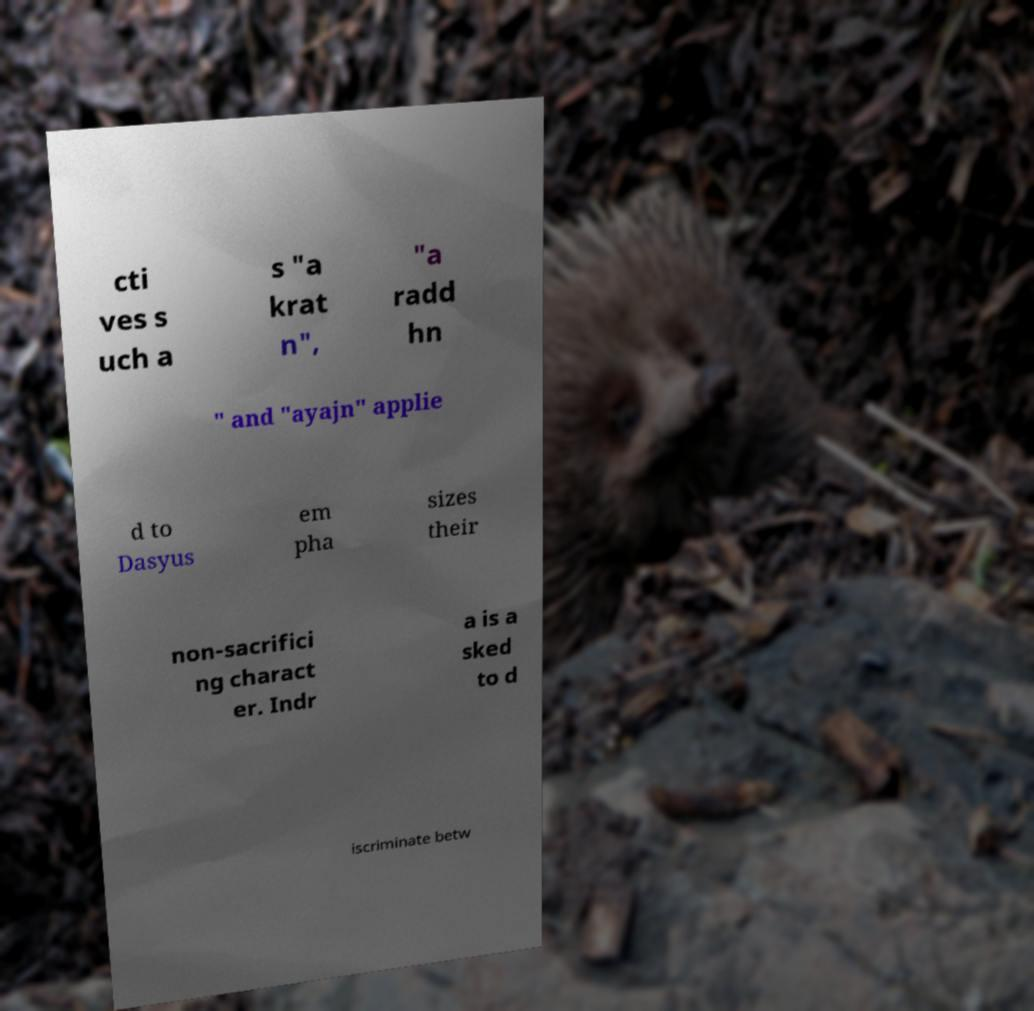What messages or text are displayed in this image? I need them in a readable, typed format. cti ves s uch a s "a krat n", "a radd hn " and "ayajn" applie d to Dasyus em pha sizes their non-sacrifici ng charact er. Indr a is a sked to d iscriminate betw 